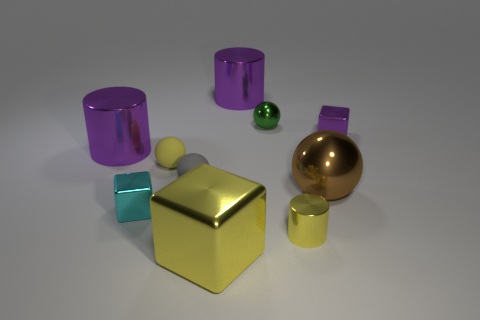Subtract all cubes. How many objects are left? 7 Add 9 tiny shiny cylinders. How many tiny shiny cylinders exist? 10 Subtract 0 brown cylinders. How many objects are left? 10 Subtract all small balls. Subtract all cyan metal balls. How many objects are left? 7 Add 1 cylinders. How many cylinders are left? 4 